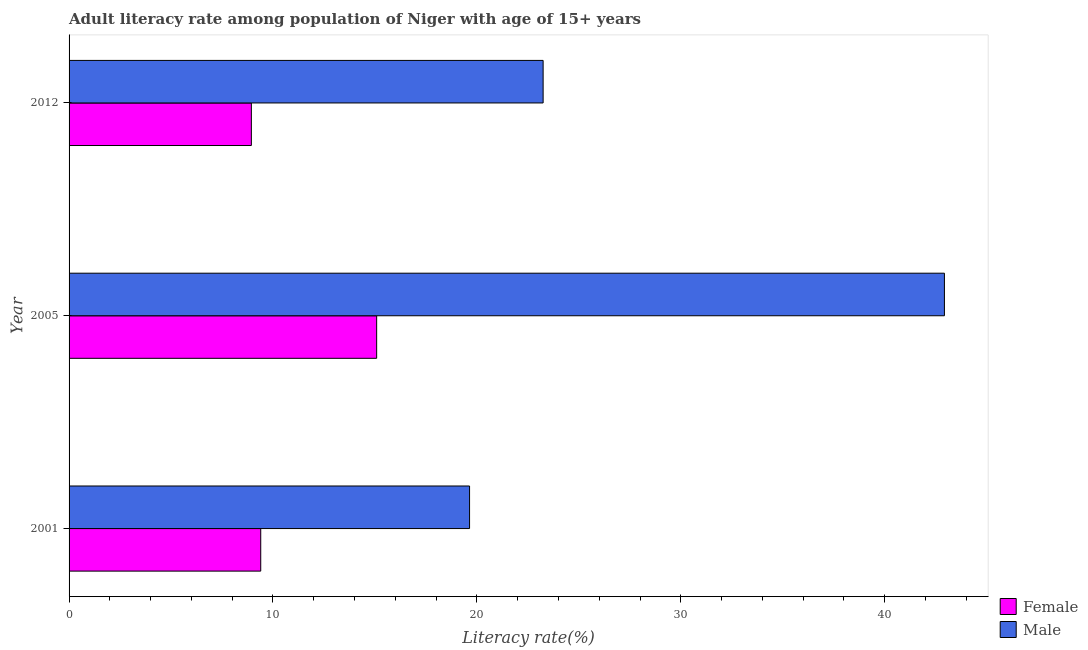How many groups of bars are there?
Provide a short and direct response. 3. How many bars are there on the 1st tick from the top?
Your answer should be compact. 2. How many bars are there on the 1st tick from the bottom?
Offer a very short reply. 2. What is the label of the 3rd group of bars from the top?
Ensure brevity in your answer.  2001. In how many cases, is the number of bars for a given year not equal to the number of legend labels?
Your answer should be compact. 0. What is the female adult literacy rate in 2012?
Ensure brevity in your answer.  8.94. Across all years, what is the maximum female adult literacy rate?
Offer a very short reply. 15.08. Across all years, what is the minimum female adult literacy rate?
Provide a succinct answer. 8.94. In which year was the male adult literacy rate maximum?
Your response must be concise. 2005. What is the total female adult literacy rate in the graph?
Your answer should be very brief. 33.42. What is the difference between the female adult literacy rate in 2005 and that in 2012?
Ensure brevity in your answer.  6.14. What is the difference between the female adult literacy rate in 2005 and the male adult literacy rate in 2001?
Your response must be concise. -4.56. What is the average male adult literacy rate per year?
Provide a succinct answer. 28.61. In the year 2001, what is the difference between the female adult literacy rate and male adult literacy rate?
Give a very brief answer. -10.24. In how many years, is the female adult literacy rate greater than 2 %?
Provide a short and direct response. 3. What is the ratio of the female adult literacy rate in 2001 to that in 2005?
Your response must be concise. 0.62. Is the male adult literacy rate in 2001 less than that in 2005?
Your answer should be very brief. Yes. Is the difference between the female adult literacy rate in 2001 and 2012 greater than the difference between the male adult literacy rate in 2001 and 2012?
Ensure brevity in your answer.  Yes. What is the difference between the highest and the second highest female adult literacy rate?
Make the answer very short. 5.68. What is the difference between the highest and the lowest female adult literacy rate?
Provide a succinct answer. 6.14. Is the sum of the female adult literacy rate in 2001 and 2005 greater than the maximum male adult literacy rate across all years?
Provide a succinct answer. No. What does the 1st bar from the bottom in 2005 represents?
Ensure brevity in your answer.  Female. How many bars are there?
Give a very brief answer. 6. Are the values on the major ticks of X-axis written in scientific E-notation?
Provide a short and direct response. No. Where does the legend appear in the graph?
Your answer should be compact. Bottom right. How many legend labels are there?
Give a very brief answer. 2. How are the legend labels stacked?
Your answer should be compact. Vertical. What is the title of the graph?
Give a very brief answer. Adult literacy rate among population of Niger with age of 15+ years. Does "Electricity" appear as one of the legend labels in the graph?
Your response must be concise. No. What is the label or title of the X-axis?
Provide a succinct answer. Literacy rate(%). What is the Literacy rate(%) in Female in 2001?
Offer a terse response. 9.4. What is the Literacy rate(%) of Male in 2001?
Provide a short and direct response. 19.64. What is the Literacy rate(%) of Female in 2005?
Your response must be concise. 15.08. What is the Literacy rate(%) in Male in 2005?
Ensure brevity in your answer.  42.93. What is the Literacy rate(%) of Female in 2012?
Offer a very short reply. 8.94. What is the Literacy rate(%) in Male in 2012?
Your answer should be compact. 23.25. Across all years, what is the maximum Literacy rate(%) of Female?
Ensure brevity in your answer.  15.08. Across all years, what is the maximum Literacy rate(%) in Male?
Your response must be concise. 42.93. Across all years, what is the minimum Literacy rate(%) of Female?
Ensure brevity in your answer.  8.94. Across all years, what is the minimum Literacy rate(%) in Male?
Make the answer very short. 19.64. What is the total Literacy rate(%) of Female in the graph?
Make the answer very short. 33.42. What is the total Literacy rate(%) of Male in the graph?
Offer a very short reply. 85.81. What is the difference between the Literacy rate(%) in Female in 2001 and that in 2005?
Offer a very short reply. -5.68. What is the difference between the Literacy rate(%) in Male in 2001 and that in 2005?
Keep it short and to the point. -23.29. What is the difference between the Literacy rate(%) in Female in 2001 and that in 2012?
Your answer should be very brief. 0.46. What is the difference between the Literacy rate(%) in Male in 2001 and that in 2012?
Your response must be concise. -3.61. What is the difference between the Literacy rate(%) in Female in 2005 and that in 2012?
Offer a very short reply. 6.14. What is the difference between the Literacy rate(%) of Male in 2005 and that in 2012?
Give a very brief answer. 19.68. What is the difference between the Literacy rate(%) in Female in 2001 and the Literacy rate(%) in Male in 2005?
Provide a succinct answer. -33.53. What is the difference between the Literacy rate(%) in Female in 2001 and the Literacy rate(%) in Male in 2012?
Keep it short and to the point. -13.85. What is the difference between the Literacy rate(%) of Female in 2005 and the Literacy rate(%) of Male in 2012?
Offer a terse response. -8.16. What is the average Literacy rate(%) of Female per year?
Provide a short and direct response. 11.14. What is the average Literacy rate(%) of Male per year?
Your answer should be very brief. 28.61. In the year 2001, what is the difference between the Literacy rate(%) in Female and Literacy rate(%) in Male?
Make the answer very short. -10.24. In the year 2005, what is the difference between the Literacy rate(%) in Female and Literacy rate(%) in Male?
Give a very brief answer. -27.84. In the year 2012, what is the difference between the Literacy rate(%) in Female and Literacy rate(%) in Male?
Offer a terse response. -14.31. What is the ratio of the Literacy rate(%) of Female in 2001 to that in 2005?
Ensure brevity in your answer.  0.62. What is the ratio of the Literacy rate(%) of Male in 2001 to that in 2005?
Provide a succinct answer. 0.46. What is the ratio of the Literacy rate(%) in Female in 2001 to that in 2012?
Give a very brief answer. 1.05. What is the ratio of the Literacy rate(%) of Male in 2001 to that in 2012?
Your answer should be compact. 0.84. What is the ratio of the Literacy rate(%) of Female in 2005 to that in 2012?
Make the answer very short. 1.69. What is the ratio of the Literacy rate(%) of Male in 2005 to that in 2012?
Give a very brief answer. 1.85. What is the difference between the highest and the second highest Literacy rate(%) in Female?
Provide a short and direct response. 5.68. What is the difference between the highest and the second highest Literacy rate(%) in Male?
Your answer should be very brief. 19.68. What is the difference between the highest and the lowest Literacy rate(%) of Female?
Make the answer very short. 6.14. What is the difference between the highest and the lowest Literacy rate(%) of Male?
Make the answer very short. 23.29. 